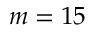Convert formula to latex. <formula><loc_0><loc_0><loc_500><loc_500>m = 1 5</formula> 